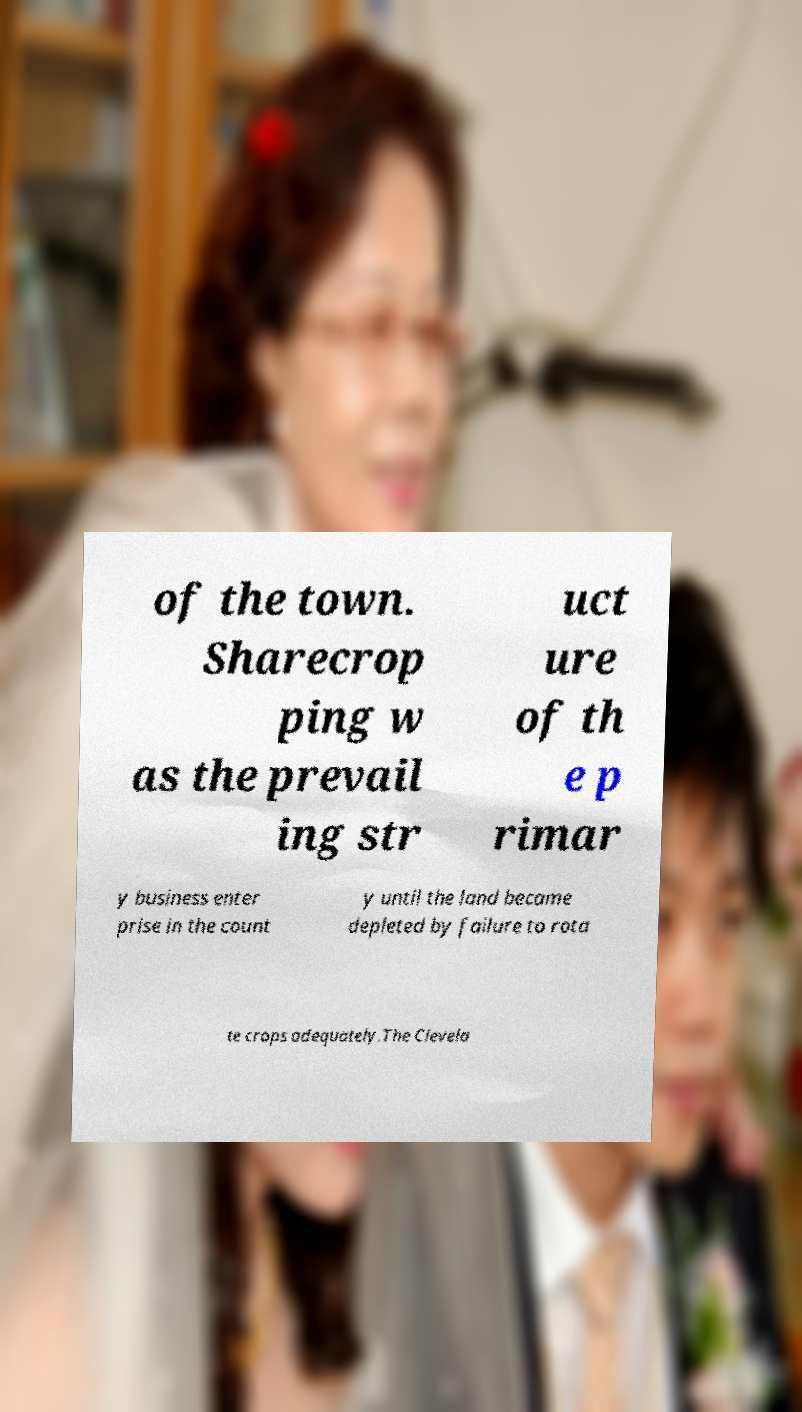Could you extract and type out the text from this image? of the town. Sharecrop ping w as the prevail ing str uct ure of th e p rimar y business enter prise in the count y until the land became depleted by failure to rota te crops adequately.The Clevela 